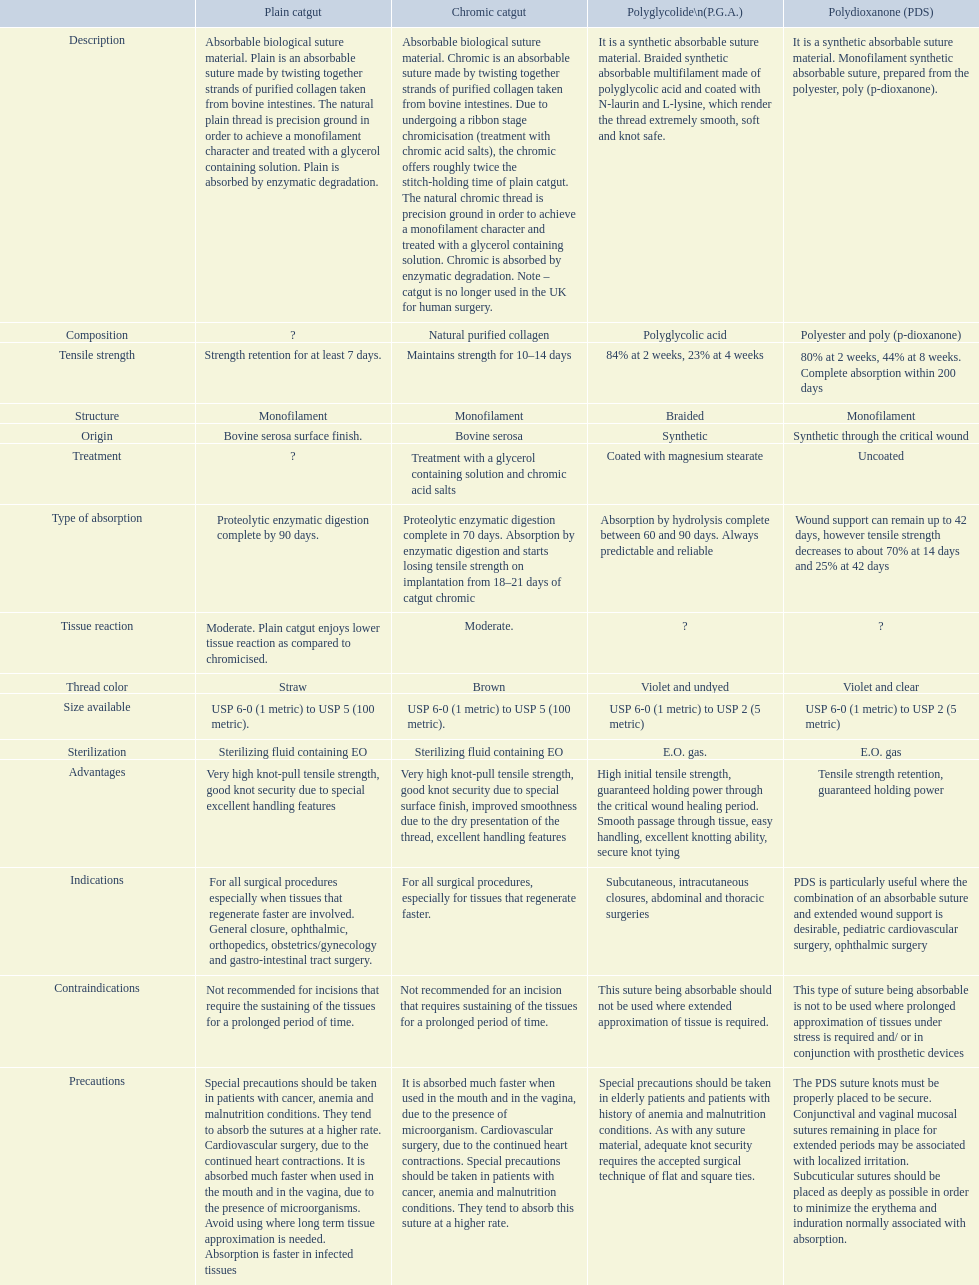What groups are displayed in the suture materials comparison chart? Description, Composition, Tensile strength, Structure, Origin, Treatment, Type of absorption, Tissue reaction, Thread color, Size available, Sterilization, Advantages, Indications, Contraindications, Precautions. Concerning the fabric strength, which is the lowest? Strength retention for at least 7 days. 